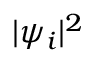<formula> <loc_0><loc_0><loc_500><loc_500>| \psi _ { i } | ^ { 2 }</formula> 